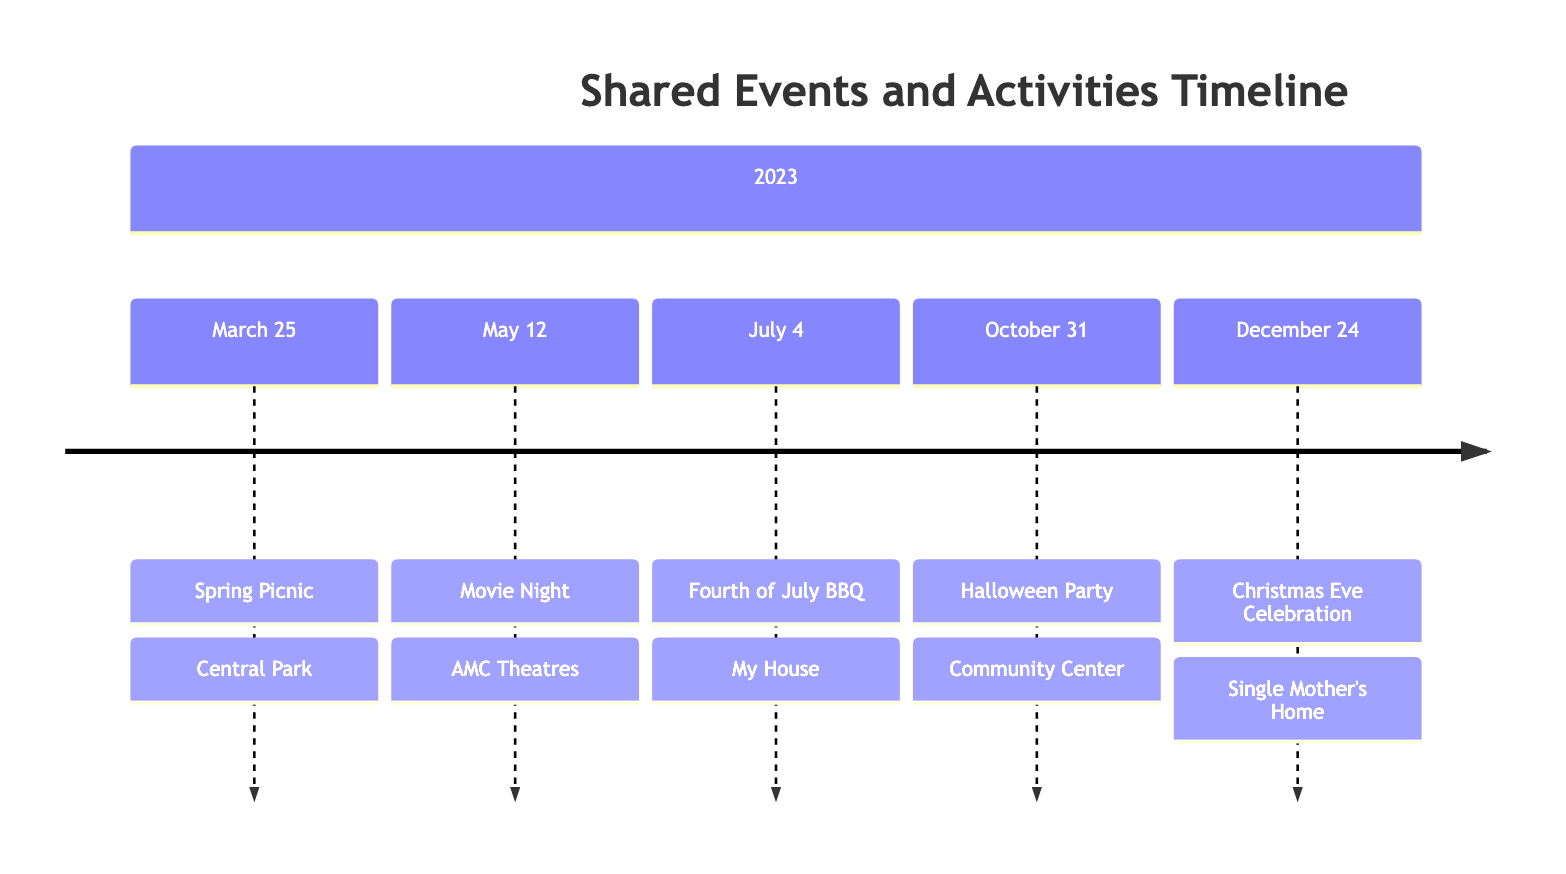What event took place on March 25, 2023? The timeline indicates that the event on March 25, 2023, is the Spring Picnic.
Answer: Spring Picnic How many events are listed in the timeline? Counting the unique entries in the timeline, there are a total of five events listed.
Answer: 5 What location was used for the Fourth of July BBQ? The timeline specifies that the location for the Fourth of July BBQ was at My House.
Answer: My House What activity was associated with the Halloween Party? The timeline describes the Halloween Party as involving costume contests, trick-or-treating, and spooky crafts, indicating multiple activities. The key activity is the neighborhood Halloween party.
Answer: Neighborhood Halloween party Which event is closest to Christmas Eve in the timeline? By looking at the dates in the timeline, the event before Christmas Eve is the Halloween Party on October 31, 2023, making it the closest event.
Answer: Halloween Party What was exchanged during the Christmas Eve Celebration? The timeline mentions that gifts were exchanged during the Christmas Eve Celebration, making it a significant part of the event.
Answer: Gifts What kind of film was watched on May 12, 2023? The timeline states that the latest animated film was watched during the Movie Night, specifically identifying the genre of the film.
Answer: Animated film Which event occurs after the Spring Picnic? The timeline shows that the event following the Spring Picnic is the Movie Night on May 12, 2023.
Answer: Movie Night What type of meal was enjoyed during the Christmas Eve Celebration? According to the timeline, a holiday meal was enjoyed during the Christmas Eve Celebration, reflecting the festive nature of the event.
Answer: Holiday meal 